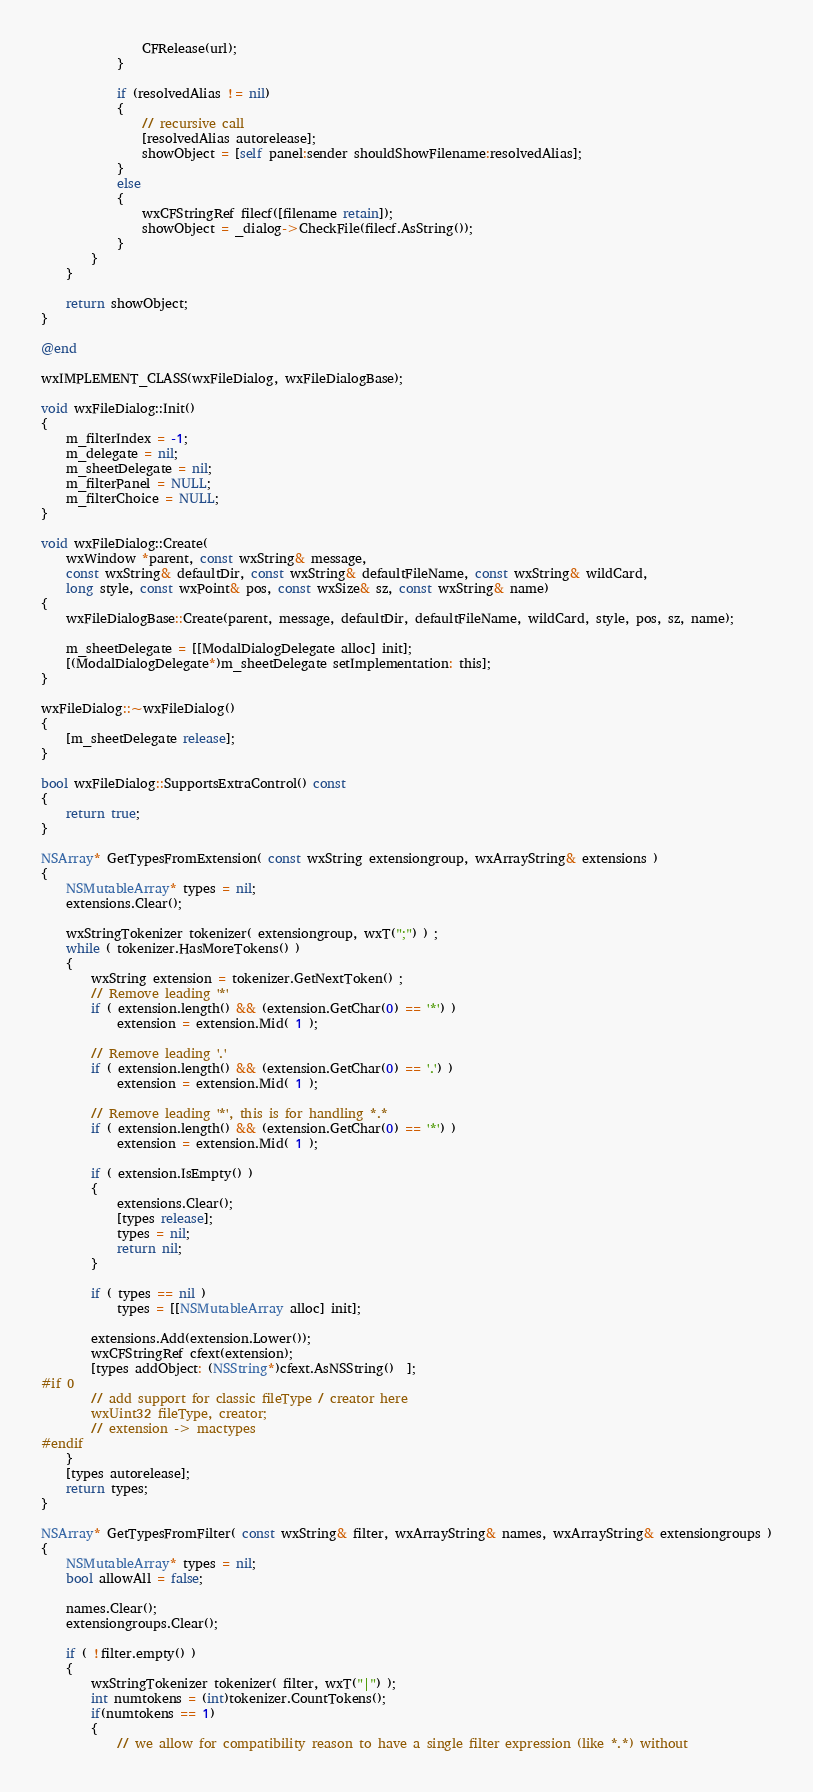<code> <loc_0><loc_0><loc_500><loc_500><_ObjectiveC_>                CFRelease(url);
            }

            if (resolvedAlias != nil) 
            {
                // recursive call
                [resolvedAlias autorelease];
                showObject = [self panel:sender shouldShowFilename:resolvedAlias];
            }
            else
            {
                wxCFStringRef filecf([filename retain]);
                showObject = _dialog->CheckFile(filecf.AsString());  
            }
        }
    }

    return showObject;    
}

@end

wxIMPLEMENT_CLASS(wxFileDialog, wxFileDialogBase);

void wxFileDialog::Init()
{
    m_filterIndex = -1;
    m_delegate = nil;
    m_sheetDelegate = nil;
    m_filterPanel = NULL;
    m_filterChoice = NULL;
}

void wxFileDialog::Create(
    wxWindow *parent, const wxString& message,
    const wxString& defaultDir, const wxString& defaultFileName, const wxString& wildCard,
    long style, const wxPoint& pos, const wxSize& sz, const wxString& name)
{
    wxFileDialogBase::Create(parent, message, defaultDir, defaultFileName, wildCard, style, pos, sz, name);

    m_sheetDelegate = [[ModalDialogDelegate alloc] init];
    [(ModalDialogDelegate*)m_sheetDelegate setImplementation: this];
}

wxFileDialog::~wxFileDialog()
{
    [m_sheetDelegate release];
}

bool wxFileDialog::SupportsExtraControl() const
{
    return true;
}

NSArray* GetTypesFromExtension( const wxString extensiongroup, wxArrayString& extensions )
{
    NSMutableArray* types = nil;
    extensions.Clear();

    wxStringTokenizer tokenizer( extensiongroup, wxT(";") ) ;
    while ( tokenizer.HasMoreTokens() )
    {
        wxString extension = tokenizer.GetNextToken() ;
        // Remove leading '*'
        if ( extension.length() && (extension.GetChar(0) == '*') )
            extension = extension.Mid( 1 );

        // Remove leading '.'
        if ( extension.length() && (extension.GetChar(0) == '.') )
            extension = extension.Mid( 1 );

        // Remove leading '*', this is for handling *.*
        if ( extension.length() && (extension.GetChar(0) == '*') )
            extension = extension.Mid( 1 );

        if ( extension.IsEmpty() )
        {
            extensions.Clear();
            [types release];
            types = nil;
            return nil;
        }

        if ( types == nil )
            types = [[NSMutableArray alloc] init];

        extensions.Add(extension.Lower());
        wxCFStringRef cfext(extension);
        [types addObject: (NSString*)cfext.AsNSString()  ];
#if 0
        // add support for classic fileType / creator here
        wxUint32 fileType, creator;
        // extension -> mactypes
#endif
    }
    [types autorelease];
    return types;
}

NSArray* GetTypesFromFilter( const wxString& filter, wxArrayString& names, wxArrayString& extensiongroups )
{
    NSMutableArray* types = nil;
    bool allowAll = false;

    names.Clear();
    extensiongroups.Clear();

    if ( !filter.empty() )
    {
        wxStringTokenizer tokenizer( filter, wxT("|") );
        int numtokens = (int)tokenizer.CountTokens();
        if(numtokens == 1)
        {
            // we allow for compatibility reason to have a single filter expression (like *.*) without</code> 